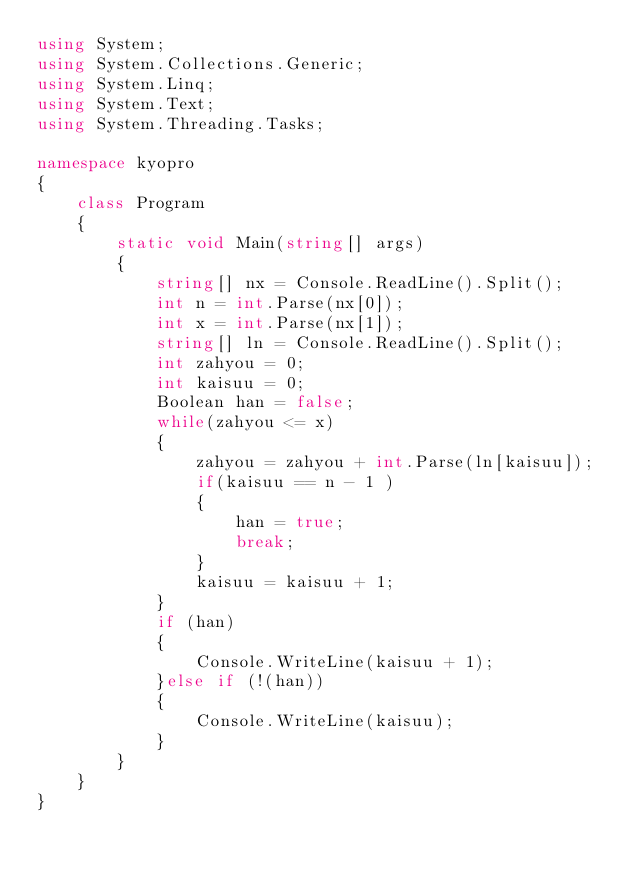Convert code to text. <code><loc_0><loc_0><loc_500><loc_500><_C#_>using System;
using System.Collections.Generic;
using System.Linq;
using System.Text;
using System.Threading.Tasks;

namespace kyopro
{
    class Program
    {
        static void Main(string[] args)
        {
            string[] nx = Console.ReadLine().Split();
            int n = int.Parse(nx[0]);
            int x = int.Parse(nx[1]);
            string[] ln = Console.ReadLine().Split();
            int zahyou = 0;
            int kaisuu = 0;
            Boolean han = false;
            while(zahyou <= x)
            {
                zahyou = zahyou + int.Parse(ln[kaisuu]);
                if(kaisuu == n - 1 )
                {
                    han = true;
                    break;
                }
                kaisuu = kaisuu + 1;
            }
            if (han)
            {
                Console.WriteLine(kaisuu + 1);
            }else if (!(han))
            {
                Console.WriteLine(kaisuu);
            }
        }
    }
}
</code> 